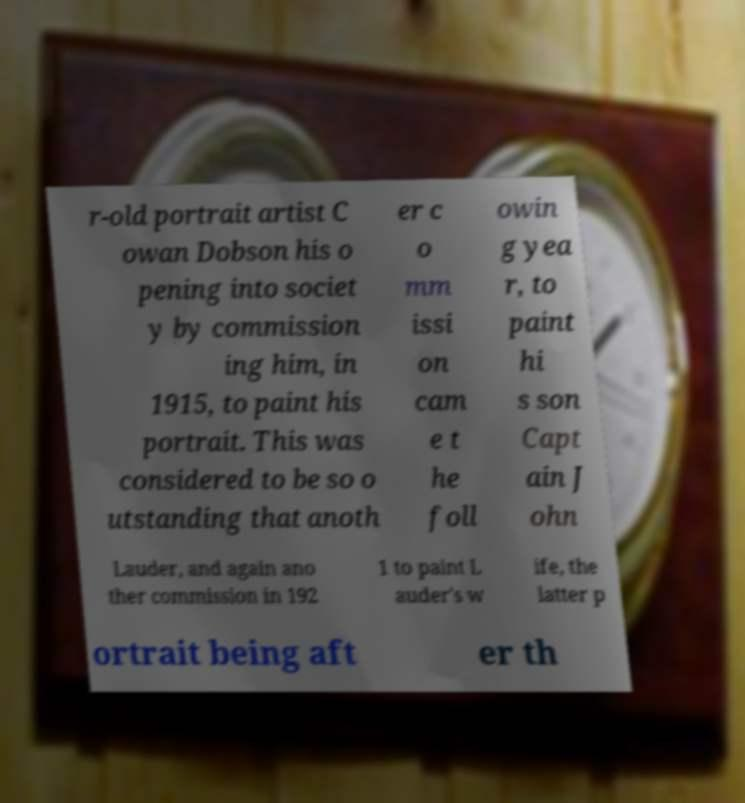For documentation purposes, I need the text within this image transcribed. Could you provide that? r-old portrait artist C owan Dobson his o pening into societ y by commission ing him, in 1915, to paint his portrait. This was considered to be so o utstanding that anoth er c o mm issi on cam e t he foll owin g yea r, to paint hi s son Capt ain J ohn Lauder, and again ano ther commission in 192 1 to paint L auder's w ife, the latter p ortrait being aft er th 